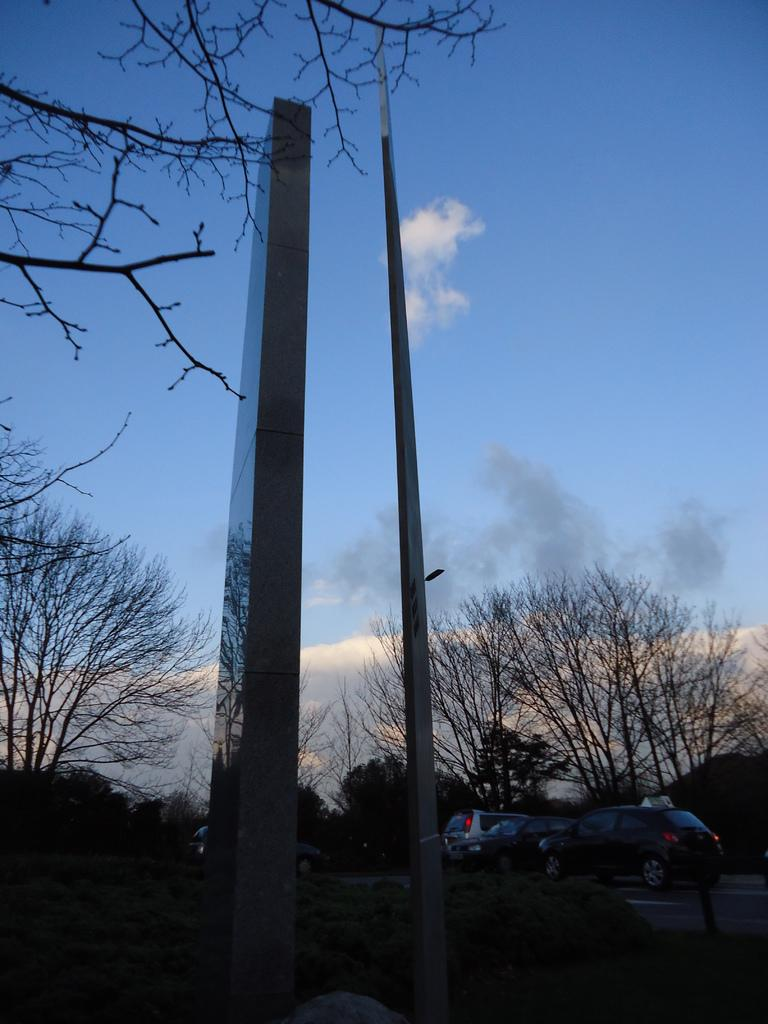What type of structure can be seen in the image? There is a pillar in the image. What else is present in the image besides the pillar? There is a pole, trees, vehicles on the road, and the sky is visible in the background. Can you describe the trees in the image? The trees are present in the image, but no specific details about their type or appearance are provided. What is visible in the sky in the image? The sky is visible in the background of the image, and there are clouds present. What type of soap is being used to clean the branch in the image? There is no branch or soap present in the image. 